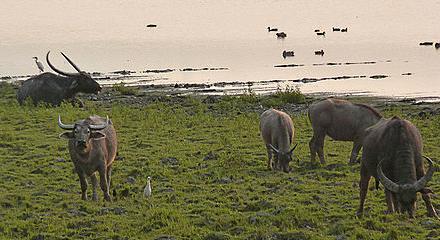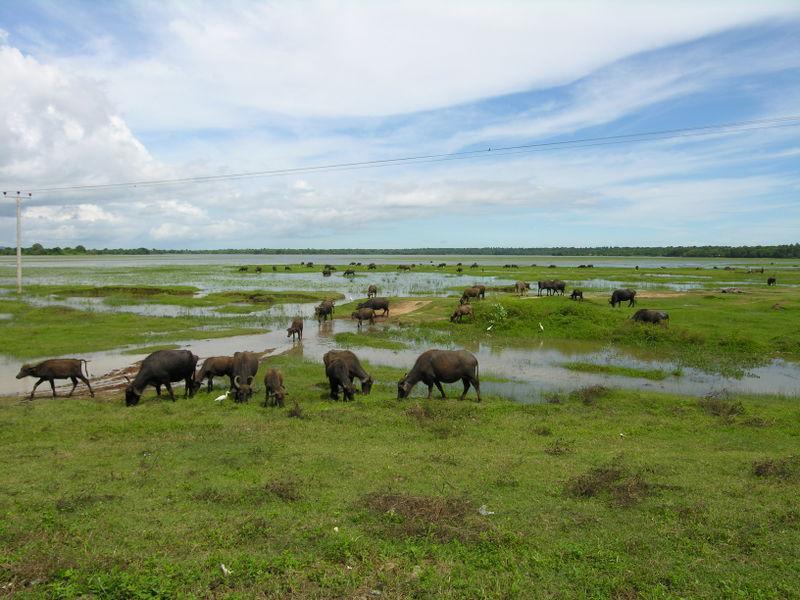The first image is the image on the left, the second image is the image on the right. Given the left and right images, does the statement "The right image shows buffalo on a green field with no water visible, and the left image shows a body of water with at least some buffalo in it, and trees behind it." hold true? Answer yes or no. No. 